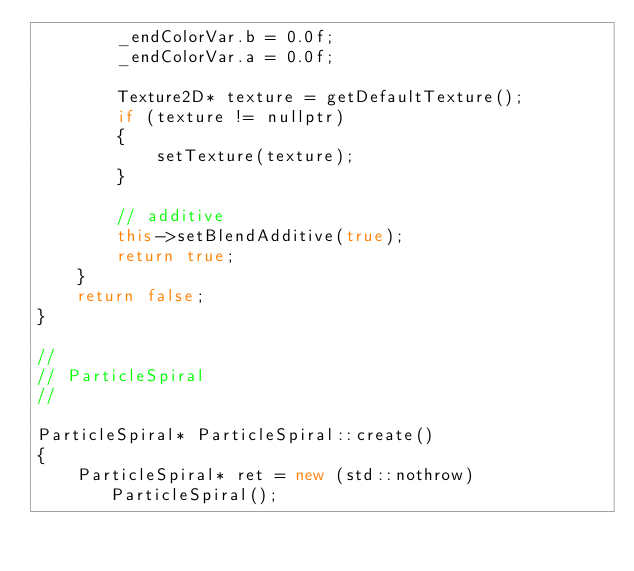Convert code to text. <code><loc_0><loc_0><loc_500><loc_500><_C++_>        _endColorVar.b = 0.0f;
        _endColorVar.a = 0.0f;

        Texture2D* texture = getDefaultTexture();
        if (texture != nullptr)
        {
            setTexture(texture);
        }

        // additive
        this->setBlendAdditive(true);
        return true;
    }
    return false;
}

//
// ParticleSpiral
//

ParticleSpiral* ParticleSpiral::create()
{
    ParticleSpiral* ret = new (std::nothrow) ParticleSpiral();</code> 